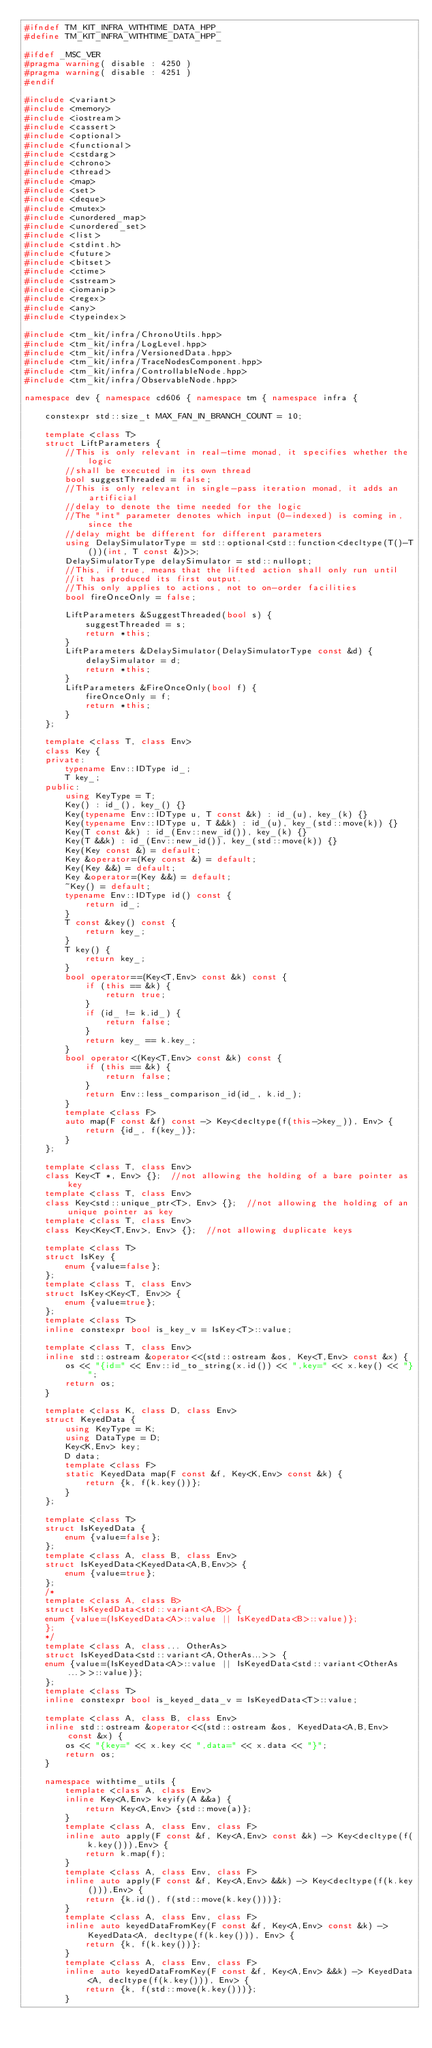<code> <loc_0><loc_0><loc_500><loc_500><_C++_>#ifndef TM_KIT_INFRA_WITHTIME_DATA_HPP_
#define TM_KIT_INFRA_WITHTIME_DATA_HPP_

#ifdef _MSC_VER
#pragma warning( disable : 4250 )
#pragma warning( disable : 4251 )
#endif

#include <variant>
#include <memory>
#include <iostream>
#include <cassert>
#include <optional>
#include <functional>
#include <cstdarg>
#include <chrono>
#include <thread>
#include <map>
#include <set>
#include <deque>
#include <mutex>
#include <unordered_map>
#include <unordered_set>
#include <list>
#include <stdint.h>
#include <future>
#include <bitset>
#include <ctime>
#include <sstream>
#include <iomanip>
#include <regex>
#include <any>
#include <typeindex>

#include <tm_kit/infra/ChronoUtils.hpp>
#include <tm_kit/infra/LogLevel.hpp>
#include <tm_kit/infra/VersionedData.hpp>
#include <tm_kit/infra/TraceNodesComponent.hpp>
#include <tm_kit/infra/ControllableNode.hpp>
#include <tm_kit/infra/ObservableNode.hpp>

namespace dev { namespace cd606 { namespace tm { namespace infra {

    constexpr std::size_t MAX_FAN_IN_BRANCH_COUNT = 10;   

    template <class T>
    struct LiftParameters {
        //This is only relevant in real-time monad, it specifies whether the logic
        //shall be executed in its own thread
        bool suggestThreaded = false;
        //This is only relevant in single-pass iteration monad, it adds an artificial
        //delay to denote the time needed for the logic 
        //The "int" parameter denotes which input (0-indexed) is coming in, since the
        //delay might be different for different parameters
        using DelaySimulatorType = std::optional<std::function<decltype(T()-T())(int, T const &)>>;
        DelaySimulatorType delaySimulator = std::nullopt;
        //This, if true, means that the lifted action shall only run until 
        //it has produced its first output. 
        //This only applies to actions, not to on-order facilities
        bool fireOnceOnly = false;

        LiftParameters &SuggestThreaded(bool s) {
            suggestThreaded = s;
            return *this;
        }
        LiftParameters &DelaySimulator(DelaySimulatorType const &d) {
            delaySimulator = d;
            return *this;
        }
        LiftParameters &FireOnceOnly(bool f) {
            fireOnceOnly = f;
            return *this;
        }
    };

    template <class T, class Env>
    class Key {
    private:
        typename Env::IDType id_;
        T key_;
    public:
        using KeyType = T;
        Key() : id_(), key_() {}
        Key(typename Env::IDType u, T const &k) : id_(u), key_(k) {}
        Key(typename Env::IDType u, T &&k) : id_(u), key_(std::move(k)) {}
        Key(T const &k) : id_(Env::new_id()), key_(k) {}
        Key(T &&k) : id_(Env::new_id()), key_(std::move(k)) {}
        Key(Key const &) = default;
        Key &operator=(Key const &) = default;
        Key(Key &&) = default;
        Key &operator=(Key &&) = default;
        ~Key() = default;
        typename Env::IDType id() const {
            return id_;
        }
        T const &key() const {
            return key_;
        }
        T key() {
            return key_;
        }
        bool operator==(Key<T,Env> const &k) const {
            if (this == &k) {
                return true;
            }
            if (id_ != k.id_) {
                return false;
            }
            return key_ == k.key_;
        }
        bool operator<(Key<T,Env> const &k) const {
            if (this == &k) {
                return false;
            }
            return Env::less_comparison_id(id_, k.id_);
        }
        template <class F>
        auto map(F const &f) const -> Key<decltype(f(this->key_)), Env> {
            return {id_, f(key_)};
        }
    };

    template <class T, class Env>
    class Key<T *, Env> {};  //not allowing the holding of a bare pointer as key
    template <class T, class Env>
    class Key<std::unique_ptr<T>, Env> {};  //not allowing the holding of an unique pointer as key
    template <class T, class Env>
    class Key<Key<T,Env>, Env> {};  //not allowing duplicate keys

    template <class T>
    struct IsKey {
        enum {value=false};
    };
    template <class T, class Env>
    struct IsKey<Key<T, Env>> {
        enum {value=true};
    };
    template <class T>
    inline constexpr bool is_key_v = IsKey<T>::value;

    template <class T, class Env>
    inline std::ostream &operator<<(std::ostream &os, Key<T,Env> const &x) {
        os << "{id=" << Env::id_to_string(x.id()) << ",key=" << x.key() << "}";
        return os;
    }

    template <class K, class D, class Env>
    struct KeyedData {
        using KeyType = K;
        using DataType = D;
        Key<K,Env> key;
        D data;
        template <class F>
        static KeyedData map(F const &f, Key<K,Env> const &k) {
            return {k, f(k.key())};
        }
    };

    template <class T>
    struct IsKeyedData {
        enum {value=false};
    };
    template <class A, class B, class Env>
    struct IsKeyedData<KeyedData<A,B,Env>> {
        enum {value=true};
    };
    /*
    template <class A, class B>
    struct IsKeyedData<std::variant<A,B>> {
	enum {value=(IsKeyedData<A>::value || IsKeyedData<B>::value)};
    };
    */
    template <class A, class... OtherAs>
    struct IsKeyedData<std::variant<A,OtherAs...>> {
	enum {value=(IsKeyedData<A>::value || IsKeyedData<std::variant<OtherAs...>>::value)};
    };
    template <class T>
    inline constexpr bool is_keyed_data_v = IsKeyedData<T>::value;

    template <class A, class B, class Env>
    inline std::ostream &operator<<(std::ostream &os, KeyedData<A,B,Env> const &x) {
        os << "{key=" << x.key << ",data=" << x.data << "}";
        return os;
    }

    namespace withtime_utils {
        template <class A, class Env>
        inline Key<A,Env> keyify(A &&a) {
            return Key<A,Env> {std::move(a)};
        }
        template <class A, class Env, class F>
        inline auto apply(F const &f, Key<A,Env> const &k) -> Key<decltype(f(k.key())),Env> {
            return k.map(f);
        }
        template <class A, class Env, class F>
        inline auto apply(F const &f, Key<A,Env> &&k) -> Key<decltype(f(k.key())),Env> {
            return {k.id(), f(std::move(k.key()))};
        }
        template <class A, class Env, class F>
        inline auto keyedDataFromKey(F const &f, Key<A,Env> const &k) -> KeyedData<A, decltype(f(k.key())), Env> {
            return {k, f(k.key())};
        }
        template <class A, class Env, class F>
        inline auto keyedDataFromKey(F const &f, Key<A,Env> &&k) -> KeyedData<A, decltype(f(k.key())), Env> {
            return {k, f(std::move(k.key()))};
        }</code> 